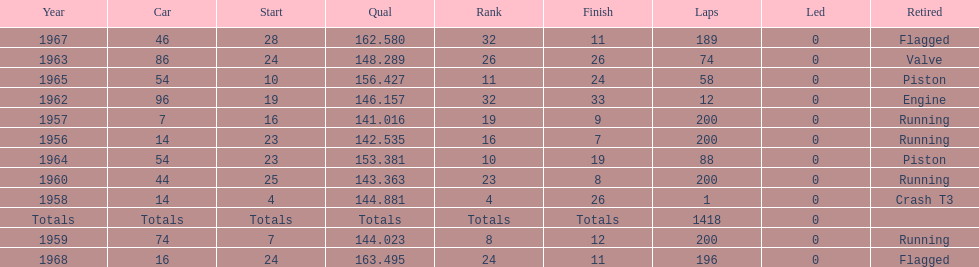How many times did he finish all 200 laps? 4. 